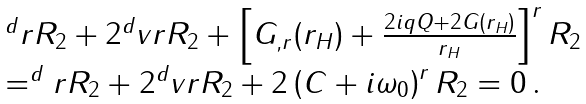Convert formula to latex. <formula><loc_0><loc_0><loc_500><loc_500>\begin{array} { l l } & ^ { d } r R _ { 2 } + 2 ^ { d } v r R _ { 2 } + \left [ G _ { , r } ( r _ { H } ) + \frac { 2 i q Q + 2 G ( r _ { H } ) } { r _ { H } } \right ] ^ { r } R _ { 2 } \\ & = ^ { d } r R _ { 2 } + 2 ^ { d } v r R _ { 2 } + 2 \left ( C + i \omega _ { 0 } \right ) ^ { r } R _ { 2 } = 0 \, . \end{array}</formula> 